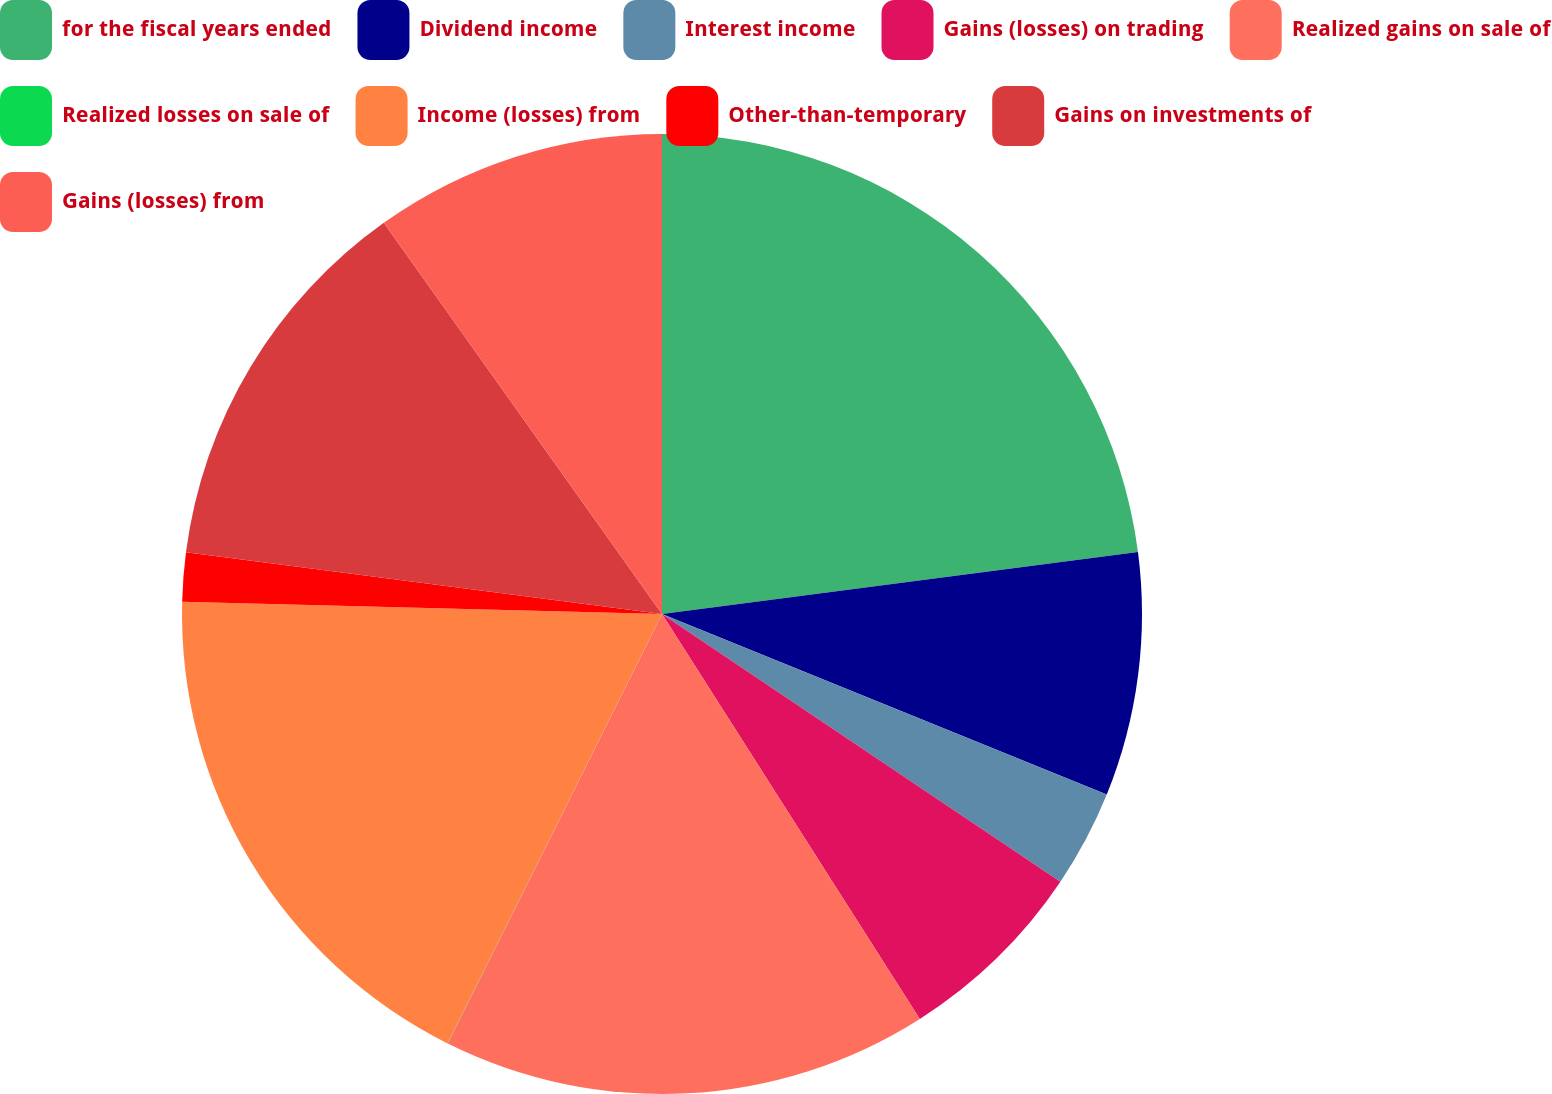<chart> <loc_0><loc_0><loc_500><loc_500><pie_chart><fcel>for the fiscal years ended<fcel>Dividend income<fcel>Interest income<fcel>Gains (losses) on trading<fcel>Realized gains on sale of<fcel>Realized losses on sale of<fcel>Income (losses) from<fcel>Other-than-temporary<fcel>Gains on investments of<fcel>Gains (losses) from<nl><fcel>22.94%<fcel>8.2%<fcel>3.28%<fcel>6.56%<fcel>16.39%<fcel>0.01%<fcel>18.03%<fcel>1.65%<fcel>13.11%<fcel>9.84%<nl></chart> 